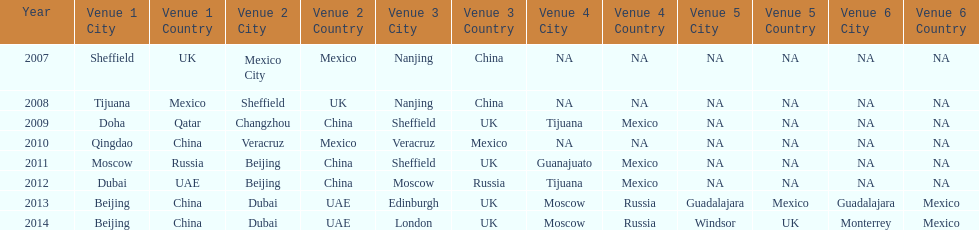How long, in years, has the this world series been occurring? 7 years. 